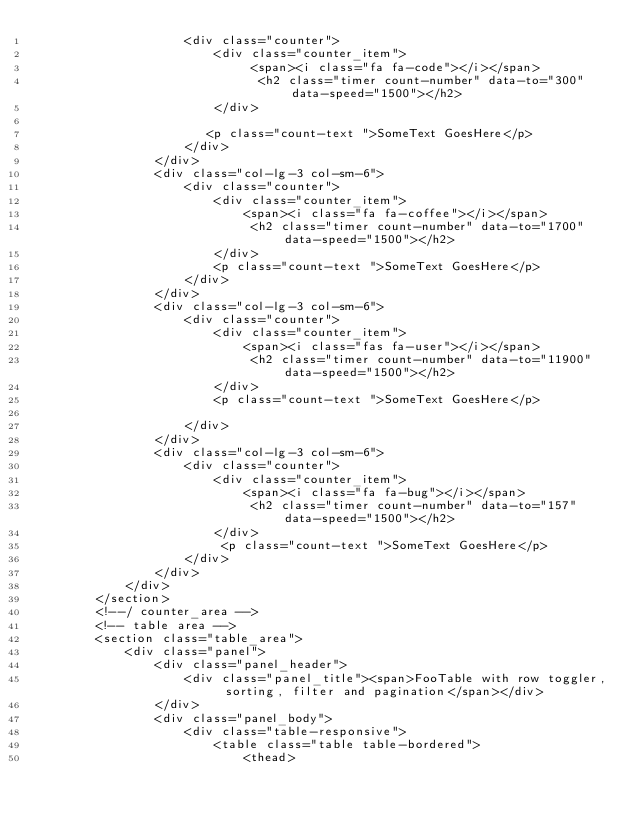<code> <loc_0><loc_0><loc_500><loc_500><_PHP_>                    <div class="counter">
                        <div class="counter_item">
                             <span><i class="fa fa-code"></i></span>
                              <h2 class="timer count-number" data-to="300" data-speed="1500"></h2>
                        </div>
                     
                       <p class="count-text ">SomeText GoesHere</p>
                    </div>
                </div>
                <div class="col-lg-3 col-sm-6">
                    <div class="counter">
                        <div class="counter_item">
                            <span><i class="fa fa-coffee"></i></span>
                             <h2 class="timer count-number" data-to="1700" data-speed="1500"></h2>
                        </div>
                        <p class="count-text ">SomeText GoesHere</p>
                    </div>
                </div>
                <div class="col-lg-3 col-sm-6">
                    <div class="counter">
                        <div class="counter_item">
                            <span><i class="fas fa-user"></i></span>
                             <h2 class="timer count-number" data-to="11900" data-speed="1500"></h2>
                        </div>
                        <p class="count-text ">SomeText GoesHere</p>
                          
                    </div>
                </div>
                <div class="col-lg-3 col-sm-6">
                    <div class="counter">
                        <div class="counter_item">
                            <span><i class="fa fa-bug"></i></span>
                             <h2 class="timer count-number" data-to="157" data-speed="1500"></h2>
                        </div>
                         <p class="count-text ">SomeText GoesHere</p>
                    </div>
                </div>
            </div>
        </section>
        <!--/ counter_area -->
        <!-- table area -->
        <section class="table_area">
            <div class="panel">
                <div class="panel_header">
                    <div class="panel_title"><span>FooTable with row toggler, sorting, filter and pagination</span></div>
                </div>
                <div class="panel_body">
                    <div class="table-responsive">
                        <table class="table table-bordered">
                            <thead></code> 